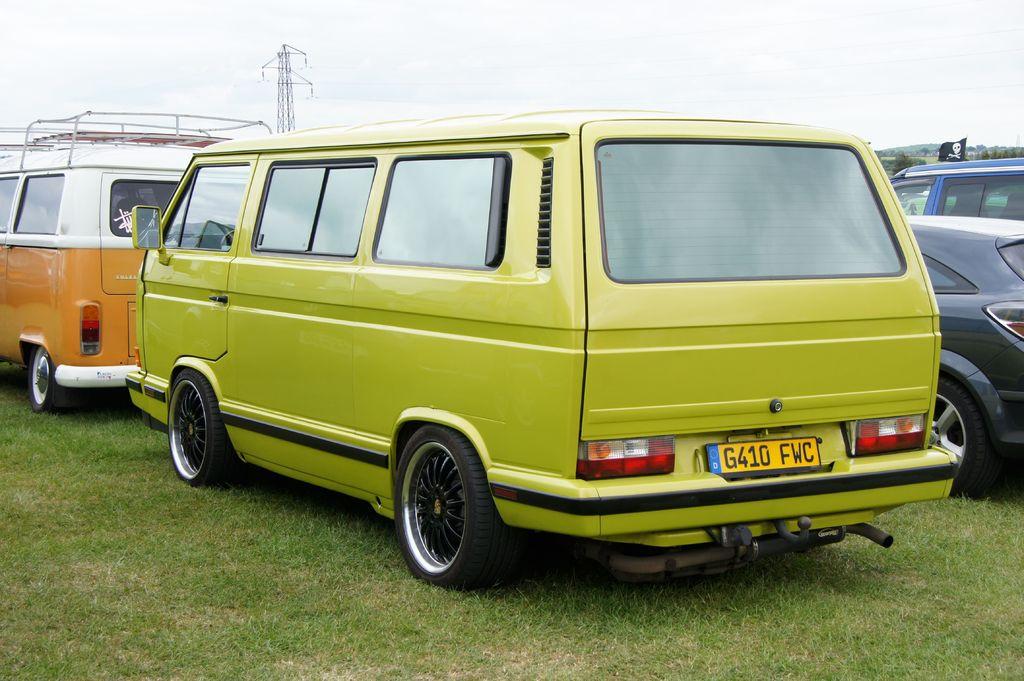What is the tag number?
Provide a succinct answer. G410 fwc. 